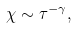Convert formula to latex. <formula><loc_0><loc_0><loc_500><loc_500>\chi \sim \tau ^ { - \gamma } ,</formula> 